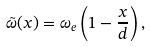<formula> <loc_0><loc_0><loc_500><loc_500>\tilde { \omega } ( x ) = \omega _ { e } \left ( 1 - \frac { x } { d } \right ) ,</formula> 